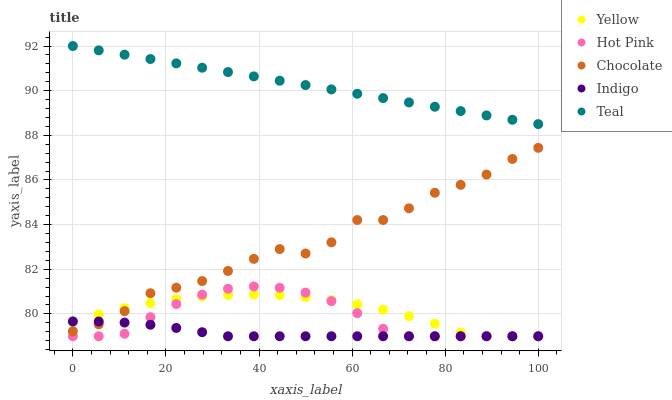Does Indigo have the minimum area under the curve?
Answer yes or no. Yes. Does Teal have the maximum area under the curve?
Answer yes or no. Yes. Does Teal have the minimum area under the curve?
Answer yes or no. No. Does Indigo have the maximum area under the curve?
Answer yes or no. No. Is Teal the smoothest?
Answer yes or no. Yes. Is Chocolate the roughest?
Answer yes or no. Yes. Is Indigo the smoothest?
Answer yes or no. No. Is Indigo the roughest?
Answer yes or no. No. Does Hot Pink have the lowest value?
Answer yes or no. Yes. Does Teal have the lowest value?
Answer yes or no. No. Does Teal have the highest value?
Answer yes or no. Yes. Does Indigo have the highest value?
Answer yes or no. No. Is Hot Pink less than Chocolate?
Answer yes or no. Yes. Is Chocolate greater than Hot Pink?
Answer yes or no. Yes. Does Hot Pink intersect Indigo?
Answer yes or no. Yes. Is Hot Pink less than Indigo?
Answer yes or no. No. Is Hot Pink greater than Indigo?
Answer yes or no. No. Does Hot Pink intersect Chocolate?
Answer yes or no. No. 